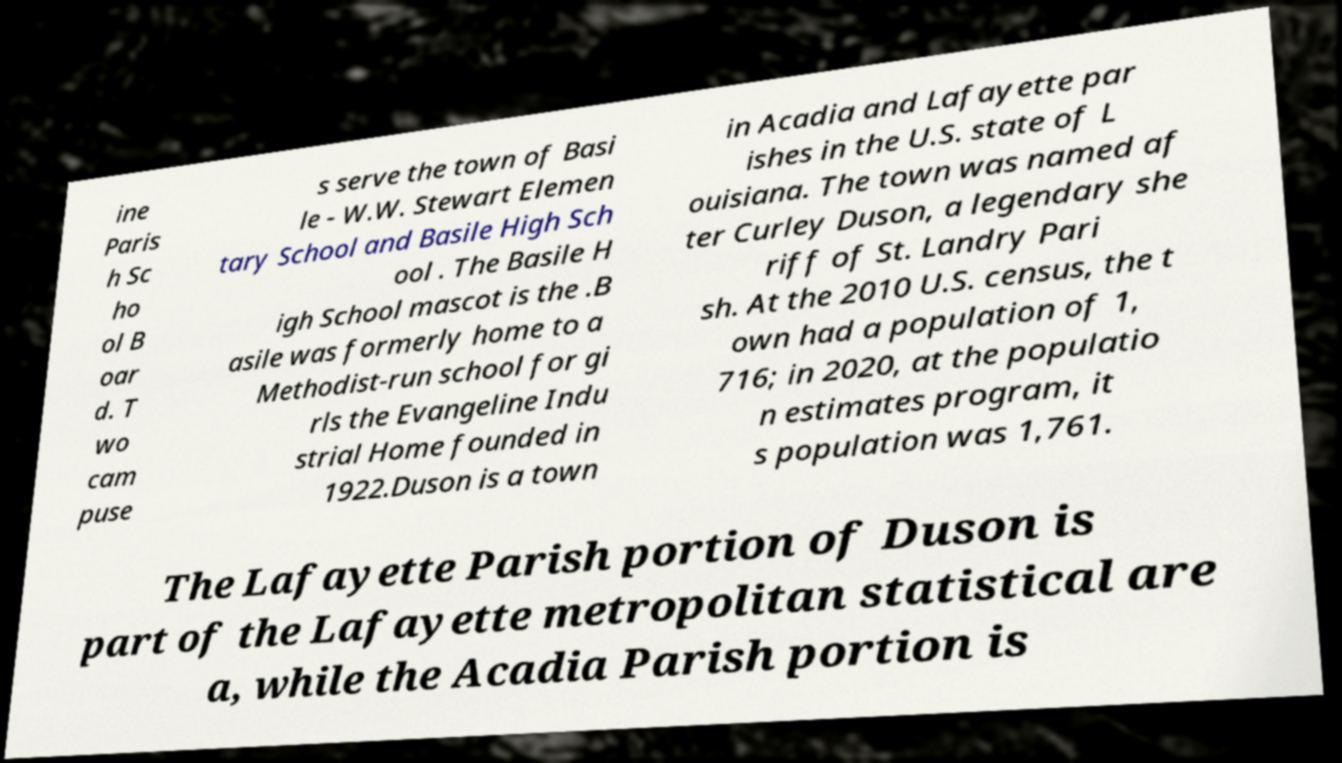Please read and relay the text visible in this image. What does it say? ine Paris h Sc ho ol B oar d. T wo cam puse s serve the town of Basi le - W.W. Stewart Elemen tary School and Basile High Sch ool . The Basile H igh School mascot is the .B asile was formerly home to a Methodist-run school for gi rls the Evangeline Indu strial Home founded in 1922.Duson is a town in Acadia and Lafayette par ishes in the U.S. state of L ouisiana. The town was named af ter Curley Duson, a legendary she riff of St. Landry Pari sh. At the 2010 U.S. census, the t own had a population of 1, 716; in 2020, at the populatio n estimates program, it s population was 1,761. The Lafayette Parish portion of Duson is part of the Lafayette metropolitan statistical are a, while the Acadia Parish portion is 